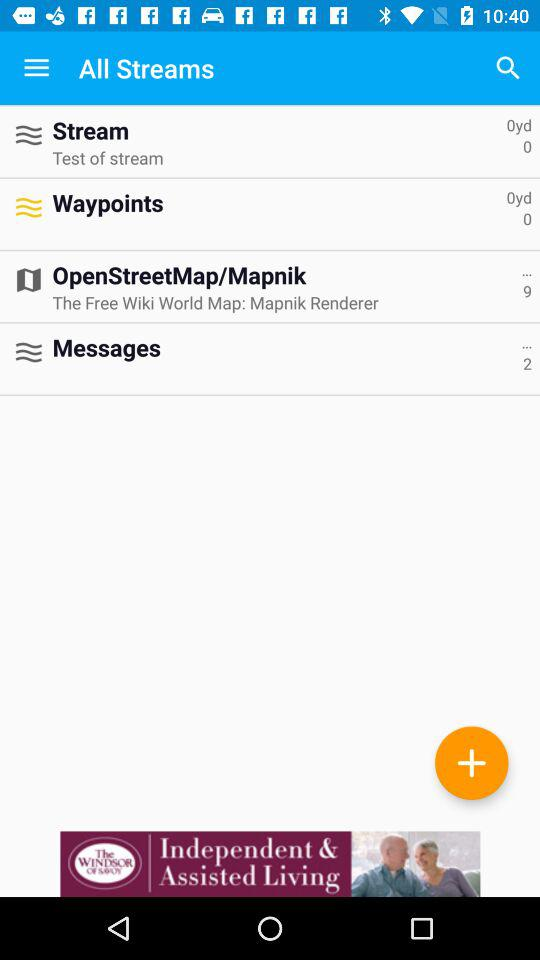How many waypoints are there? There are 0 waypoints. 